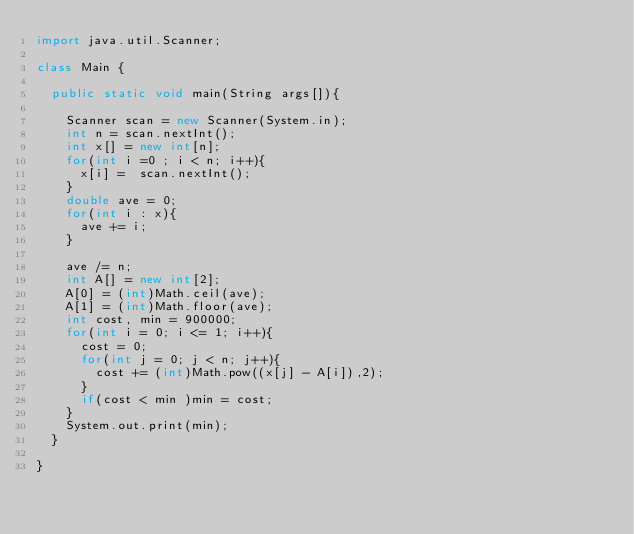<code> <loc_0><loc_0><loc_500><loc_500><_Java_>import java.util.Scanner;

class Main {

	public static void main(String args[]){

		Scanner scan = new Scanner(System.in);
		int n = scan.nextInt();
		int x[] = new int[n];
		for(int i =0 ; i < n; i++){
			x[i] =  scan.nextInt();
		}
		double ave = 0;
		for(int i : x){
			ave += i;
		}
		
		ave /= n;
		int A[] = new int[2];
		A[0] = (int)Math.ceil(ave);
		A[1] = (int)Math.floor(ave);
		int cost, min = 900000;
		for(int i = 0; i <= 1; i++){
			cost = 0;
			for(int j = 0; j < n; j++){
				cost += (int)Math.pow((x[j] - A[i]),2);
			}
			if(cost < min )min = cost;
		}
		System.out.print(min);
	}

}
</code> 